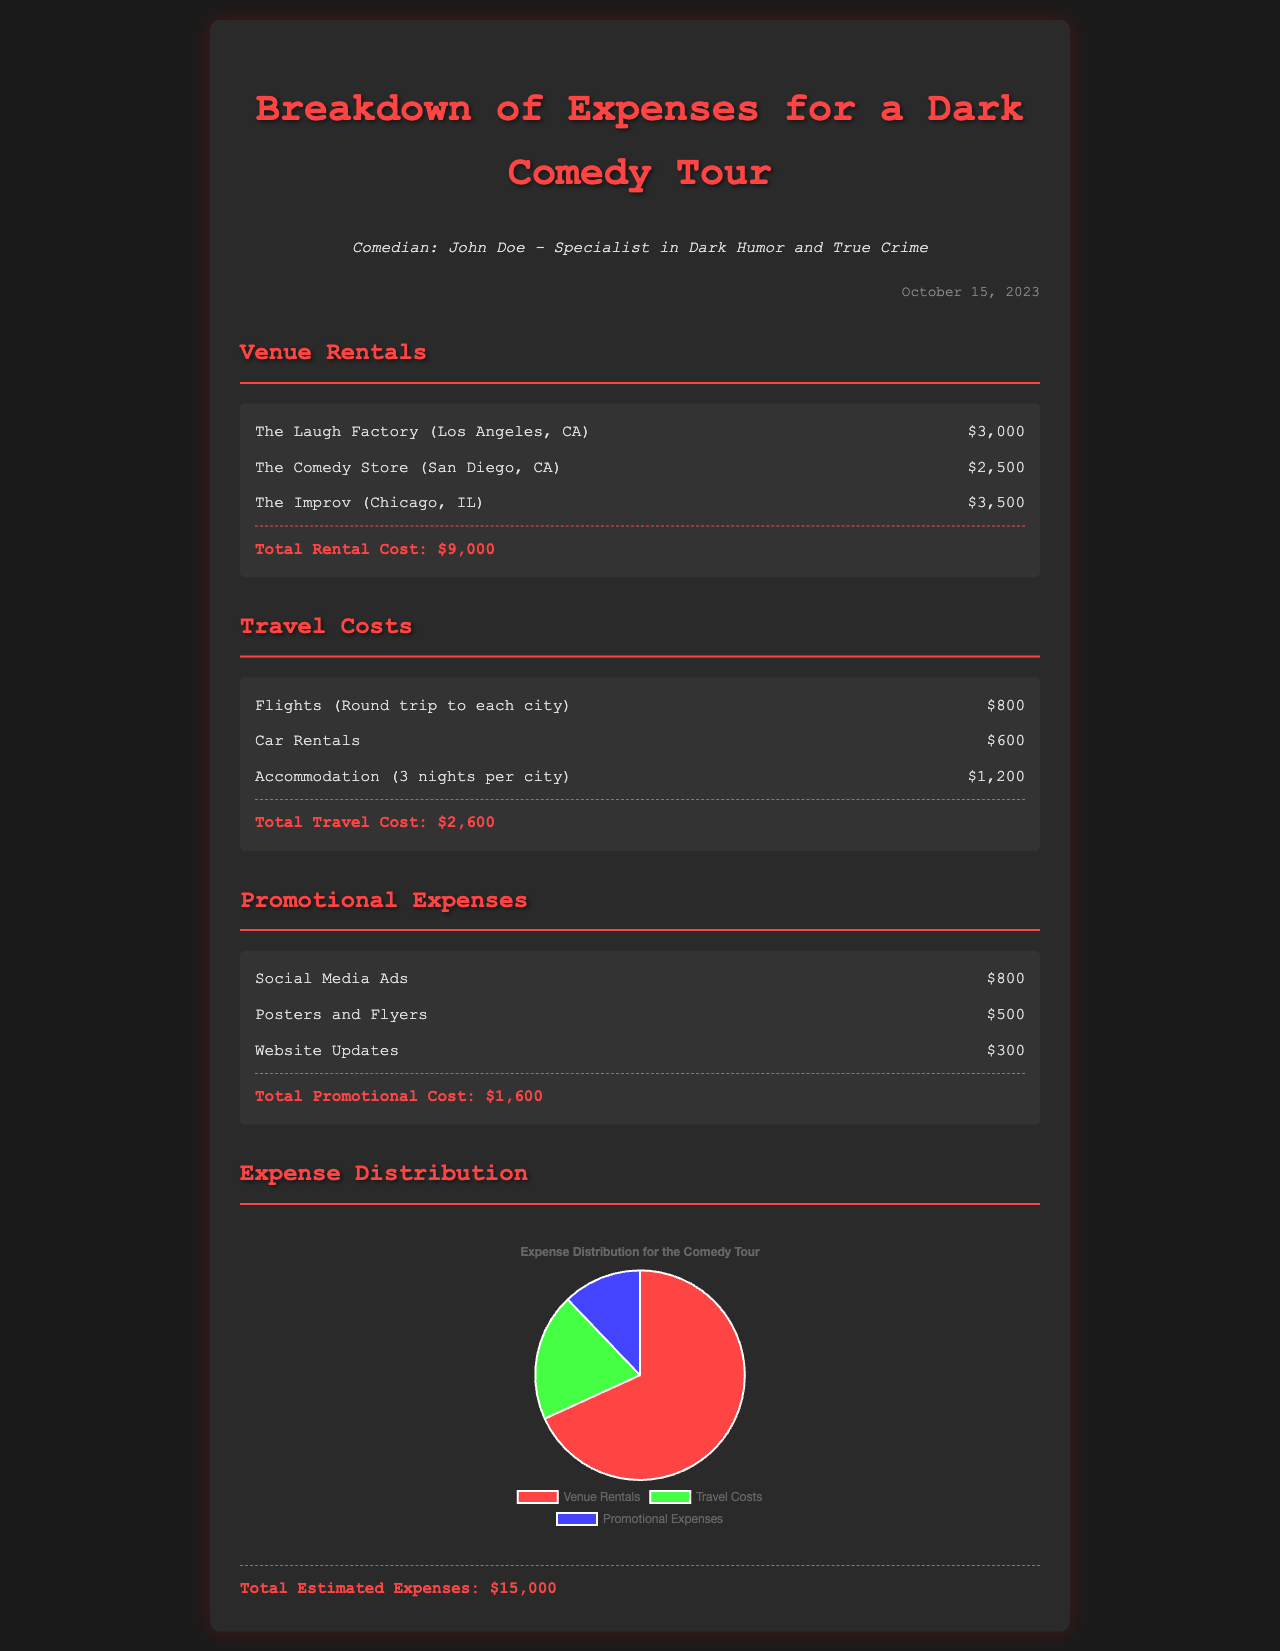What is the total rental cost? The total rental cost is the sum of all venue rentals listed in the document, which is $3,000 + $2,500 + $3,500 = $9,000.
Answer: $9,000 How much was spent on social media ads? The document lists the cost for social media ads under promotional expenses, which is $800.
Answer: $800 What percentage of the total expenses was allocated to venue rentals? Venue rentals amounted to $9,000 out of the total estimated expenses of $15,000, which is calculated as (9,000 / 15,000) * 100 = 60%.
Answer: 60% How many nights of accommodation were factored into travel costs? The document states that accommodation costs are based on 3 nights per city, which is explicitly mentioned in the travel costs section.
Answer: 3 nights What is the total estimated expenses for the comedy tour? The total estimated expenses are given explicitly in the document as $15,000.
Answer: $15,000 Which city had the highest venue rental cost? The document lists the venue rentals, and The Improv (Chicago, IL) has the highest cost at $3,500.
Answer: Chicago, IL How much was spent on posters and flyers? The document specifies the spending on posters and flyers under promotional expenses as $500.
Answer: $500 What is the total travel cost? The total travel cost is the sum of all travel-related expenses detailed in the document, which is $800 + $600 + $1,200 = $2,600.
Answer: $2,600 